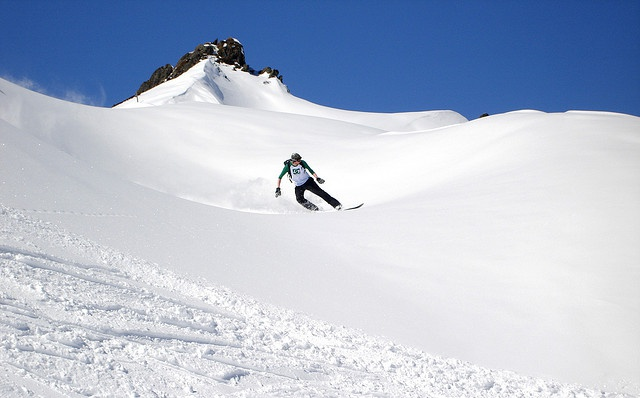Describe the objects in this image and their specific colors. I can see people in blue, black, lavender, gray, and darkgray tones and snowboard in blue, white, gray, darkgray, and black tones in this image. 